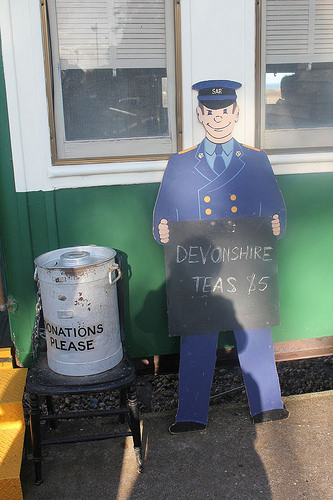<image>
Can you confirm if the chair is next to the door step? Yes. The chair is positioned adjacent to the door step, located nearby in the same general area. 